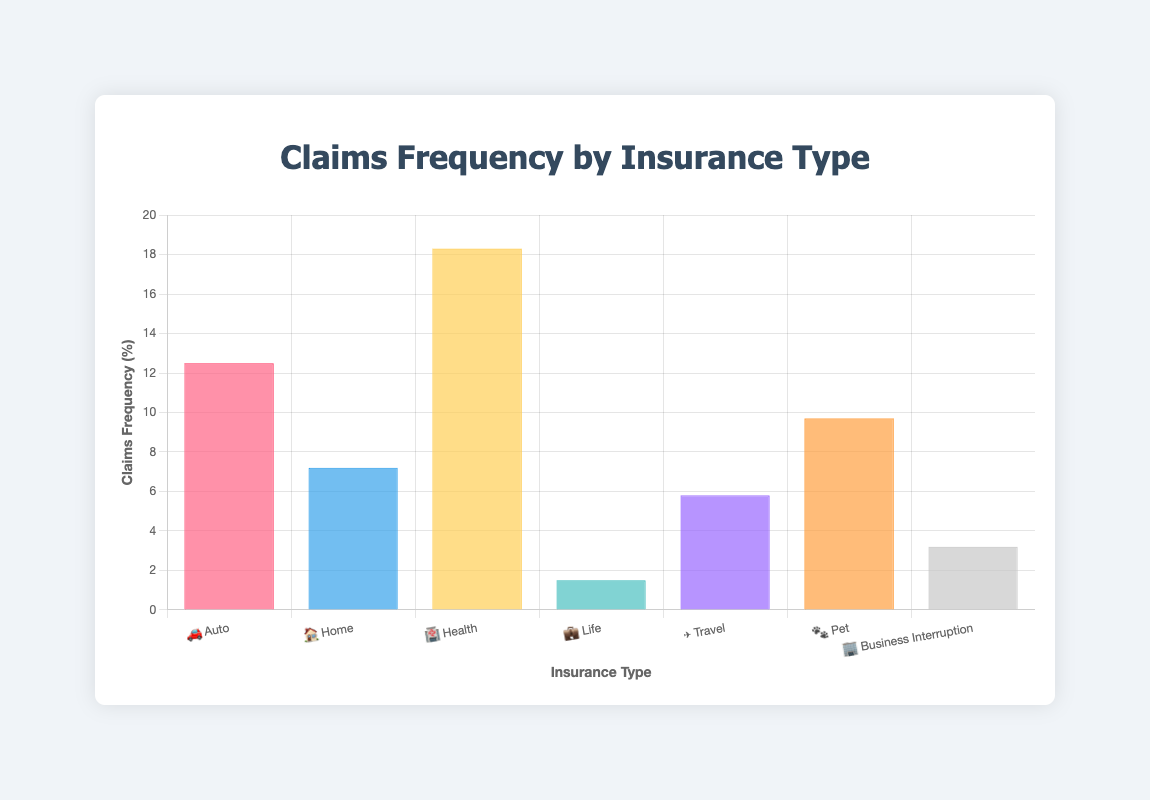What's the title of the chart? The title is prominently placed at the top of the chart, reading "Claims Frequency by Insurance Type."
Answer: Claims Frequency by Insurance Type What is the insurance type with the highest claims frequency? By inspecting the y-axis and the height of the bars, the insurance type with the highest frequency is represented by the tallest bar. The "Health" insurance type, indicated by the emoji 🏥, has the highest frequency at 18.3%.
Answer: Health What are the claims frequencies for Auto and Travel insurance types respectively? The bars labeled with "🚗 Auto" and "✈️ Travel" show the frequencies for these insurance types. The Auto insurance type has a frequency of 12.5%, and the Travel insurance type has a frequency of 5.8%.
Answer: 12.5% for Auto and 5.8% for Travel How many insurance types have a claims frequency greater than 10%? By inspecting each bar, we see that "Auto" (12.5%), "Health" (18.3%), and "Pet" (9.7%) are the only insurance types with frequencies greater than 10%. Counting these gives us three insurance types.
Answer: Three Which insurance type has the least claims frequency and what is it? The shortest bar on the chart represents the insurance type with the least frequency. "Life" insurance, represented by the emoji 💼, has the lowest frequency at 1.5%.
Answer: Life, 1.5% What is the average claims frequency for Pet, Home, and Business Interruption? To find the average, sum the frequencies for Pet (9.7%), Home (7.2%), and Business Interruption (3.2%) and then divide by the number of insurance types (3): (9.7 + 7.2 + 3.2) / 3 = 20.1 / 3 = 6.7%.
Answer: 6.7% If combined, what is the total claims frequency for Home and Travel insurance types? Add the frequencies for Home (7.2%) and Travel (5.8%): 7.2 + 5.8 = 13.0%.
Answer: 13.0% Which insurance types have a claims frequency less than 6%? By inspecting the y-axis and the height of the bars, the insurance types with frequencies less than 6% are "Life" (1.5%), "Travel" (5.8%), and "Business Interruption" (3.2%).
Answer: Life, Travel, Business Interruption Which two insurance types have the closest claims frequencies? By comparing the bars, "Home" (7.2%) and "Pet" (9.7%) are the closest in frequency among all insurance types. The difference between them is 9.7% - 7.2% = 2.5%.
Answer: Home and Pet 